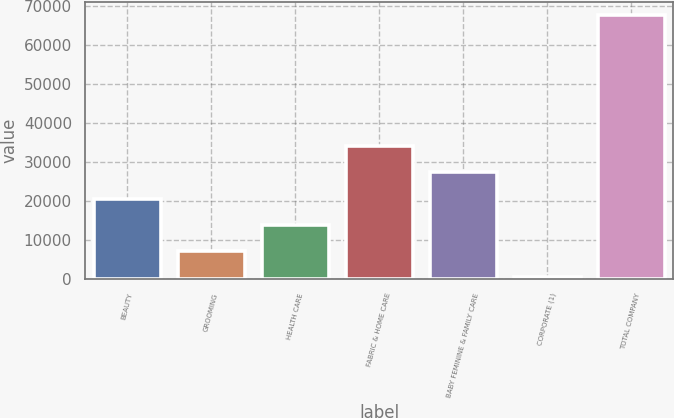Convert chart to OTSL. <chart><loc_0><loc_0><loc_500><loc_500><bar_chart><fcel>BEAUTY<fcel>GROOMING<fcel>HEALTH CARE<fcel>FABRIC & HOME CARE<fcel>BABY FEMININE & FAMILY CARE<fcel>CORPORATE (1)<fcel>TOTAL COMPANY<nl><fcel>20644<fcel>7204<fcel>13924<fcel>34084<fcel>27364<fcel>484<fcel>67684<nl></chart> 